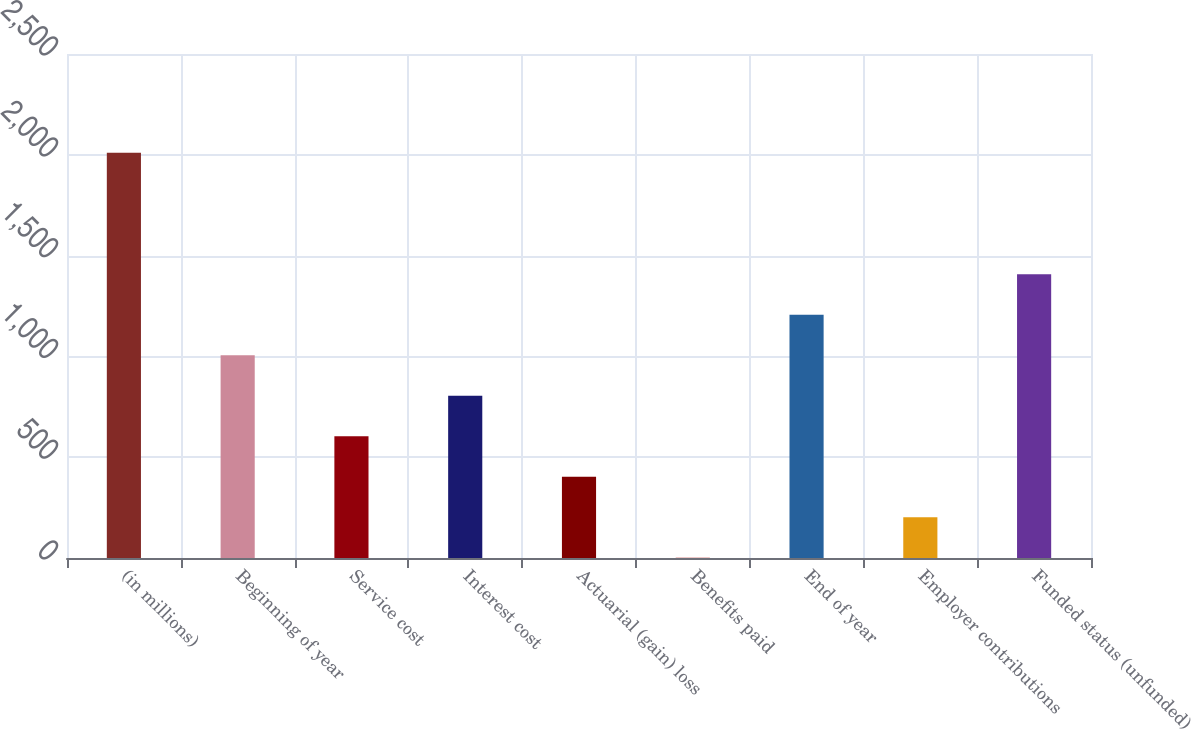Convert chart. <chart><loc_0><loc_0><loc_500><loc_500><bar_chart><fcel>(in millions)<fcel>Beginning of year<fcel>Service cost<fcel>Interest cost<fcel>Actuarial (gain) loss<fcel>Benefits paid<fcel>End of year<fcel>Employer contributions<fcel>Funded status (unfunded)<nl><fcel>2010<fcel>1005.85<fcel>604.19<fcel>805.02<fcel>403.36<fcel>1.7<fcel>1206.68<fcel>202.53<fcel>1407.51<nl></chart> 